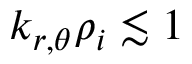Convert formula to latex. <formula><loc_0><loc_0><loc_500><loc_500>k _ { r , \theta } \rho _ { i } \lesssim 1</formula> 